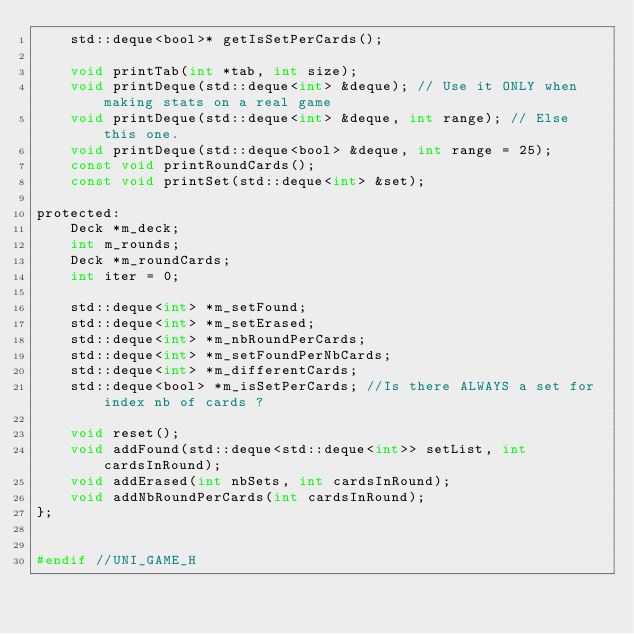Convert code to text. <code><loc_0><loc_0><loc_500><loc_500><_C_>    std::deque<bool>* getIsSetPerCards();

    void printTab(int *tab, int size);
    void printDeque(std::deque<int> &deque); // Use it ONLY when making stats on a real game
    void printDeque(std::deque<int> &deque, int range); // Else this one.
    void printDeque(std::deque<bool> &deque, int range = 25);
    const void printRoundCards();
    const void printSet(std::deque<int> &set);

protected:
    Deck *m_deck;
    int m_rounds;
    Deck *m_roundCards;
    int iter = 0;

    std::deque<int> *m_setFound;
    std::deque<int> *m_setErased;
    std::deque<int> *m_nbRoundPerCards;
    std::deque<int> *m_setFoundPerNbCards;
    std::deque<int> *m_differentCards;
    std::deque<bool> *m_isSetPerCards; //Is there ALWAYS a set for index nb of cards ?

    void reset();
    void addFound(std::deque<std::deque<int>> setList, int cardsInRound);
    void addErased(int nbSets, int cardsInRound);
    void addNbRoundPerCards(int cardsInRound);
};


#endif //UNI_GAME_H
</code> 